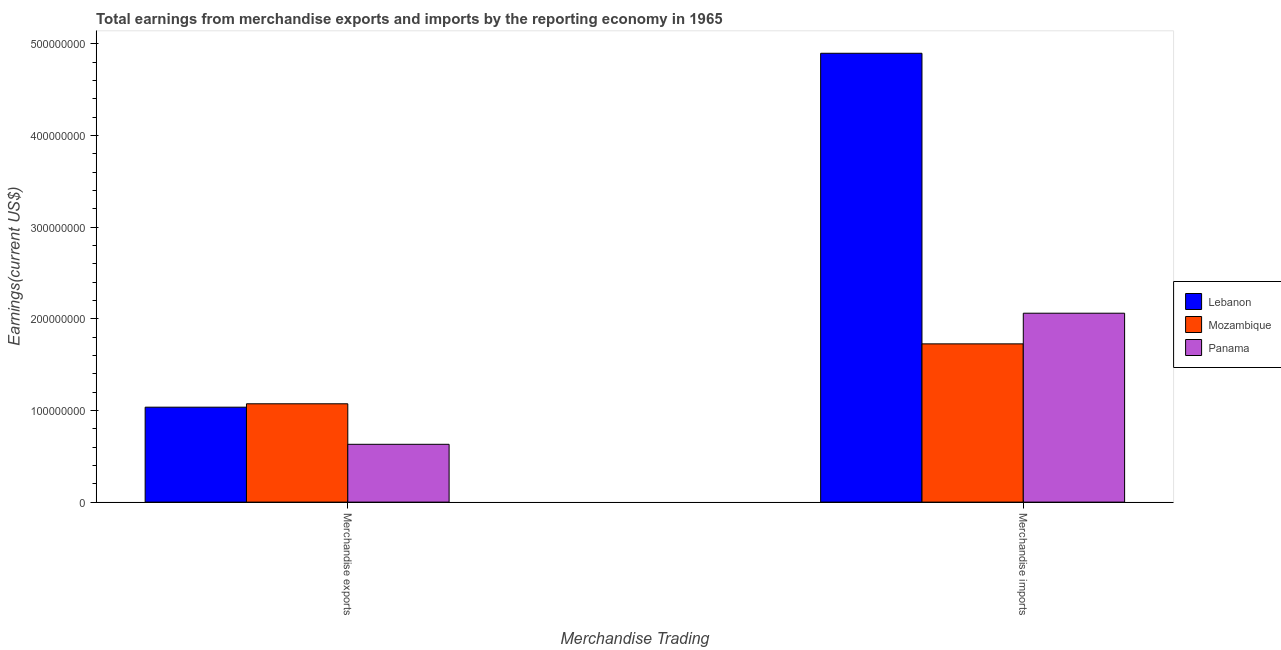How many different coloured bars are there?
Your response must be concise. 3. How many groups of bars are there?
Offer a terse response. 2. Are the number of bars per tick equal to the number of legend labels?
Your response must be concise. Yes. How many bars are there on the 2nd tick from the left?
Offer a very short reply. 3. What is the earnings from merchandise imports in Mozambique?
Your answer should be very brief. 1.73e+08. Across all countries, what is the maximum earnings from merchandise exports?
Provide a succinct answer. 1.07e+08. Across all countries, what is the minimum earnings from merchandise imports?
Make the answer very short. 1.73e+08. In which country was the earnings from merchandise exports maximum?
Keep it short and to the point. Mozambique. In which country was the earnings from merchandise imports minimum?
Your answer should be compact. Mozambique. What is the total earnings from merchandise exports in the graph?
Make the answer very short. 2.74e+08. What is the difference between the earnings from merchandise imports in Lebanon and that in Panama?
Offer a very short reply. 2.84e+08. What is the difference between the earnings from merchandise exports in Lebanon and the earnings from merchandise imports in Mozambique?
Provide a succinct answer. -6.91e+07. What is the average earnings from merchandise imports per country?
Make the answer very short. 2.90e+08. What is the difference between the earnings from merchandise imports and earnings from merchandise exports in Mozambique?
Provide a succinct answer. 6.54e+07. In how many countries, is the earnings from merchandise exports greater than 60000000 US$?
Make the answer very short. 3. What is the ratio of the earnings from merchandise imports in Mozambique to that in Panama?
Offer a very short reply. 0.84. What does the 2nd bar from the left in Merchandise exports represents?
Give a very brief answer. Mozambique. What does the 1st bar from the right in Merchandise imports represents?
Give a very brief answer. Panama. How many countries are there in the graph?
Give a very brief answer. 3. Are the values on the major ticks of Y-axis written in scientific E-notation?
Make the answer very short. No. Does the graph contain grids?
Offer a very short reply. No. How are the legend labels stacked?
Your answer should be compact. Vertical. What is the title of the graph?
Offer a very short reply. Total earnings from merchandise exports and imports by the reporting economy in 1965. What is the label or title of the X-axis?
Your response must be concise. Merchandise Trading. What is the label or title of the Y-axis?
Provide a short and direct response. Earnings(current US$). What is the Earnings(current US$) in Lebanon in Merchandise exports?
Your answer should be very brief. 1.04e+08. What is the Earnings(current US$) in Mozambique in Merchandise exports?
Offer a very short reply. 1.07e+08. What is the Earnings(current US$) of Panama in Merchandise exports?
Offer a very short reply. 6.31e+07. What is the Earnings(current US$) of Lebanon in Merchandise imports?
Your answer should be compact. 4.90e+08. What is the Earnings(current US$) in Mozambique in Merchandise imports?
Provide a succinct answer. 1.73e+08. What is the Earnings(current US$) in Panama in Merchandise imports?
Keep it short and to the point. 2.06e+08. Across all Merchandise Trading, what is the maximum Earnings(current US$) in Lebanon?
Make the answer very short. 4.90e+08. Across all Merchandise Trading, what is the maximum Earnings(current US$) in Mozambique?
Keep it short and to the point. 1.73e+08. Across all Merchandise Trading, what is the maximum Earnings(current US$) in Panama?
Give a very brief answer. 2.06e+08. Across all Merchandise Trading, what is the minimum Earnings(current US$) in Lebanon?
Make the answer very short. 1.04e+08. Across all Merchandise Trading, what is the minimum Earnings(current US$) of Mozambique?
Make the answer very short. 1.07e+08. Across all Merchandise Trading, what is the minimum Earnings(current US$) in Panama?
Your answer should be compact. 6.31e+07. What is the total Earnings(current US$) of Lebanon in the graph?
Offer a terse response. 5.93e+08. What is the total Earnings(current US$) in Mozambique in the graph?
Provide a short and direct response. 2.80e+08. What is the total Earnings(current US$) of Panama in the graph?
Your answer should be very brief. 2.69e+08. What is the difference between the Earnings(current US$) of Lebanon in Merchandise exports and that in Merchandise imports?
Offer a very short reply. -3.86e+08. What is the difference between the Earnings(current US$) of Mozambique in Merchandise exports and that in Merchandise imports?
Keep it short and to the point. -6.54e+07. What is the difference between the Earnings(current US$) in Panama in Merchandise exports and that in Merchandise imports?
Your response must be concise. -1.43e+08. What is the difference between the Earnings(current US$) in Lebanon in Merchandise exports and the Earnings(current US$) in Mozambique in Merchandise imports?
Make the answer very short. -6.91e+07. What is the difference between the Earnings(current US$) in Lebanon in Merchandise exports and the Earnings(current US$) in Panama in Merchandise imports?
Ensure brevity in your answer.  -1.03e+08. What is the difference between the Earnings(current US$) in Mozambique in Merchandise exports and the Earnings(current US$) in Panama in Merchandise imports?
Make the answer very short. -9.88e+07. What is the average Earnings(current US$) of Lebanon per Merchandise Trading?
Make the answer very short. 2.97e+08. What is the average Earnings(current US$) of Mozambique per Merchandise Trading?
Offer a terse response. 1.40e+08. What is the average Earnings(current US$) in Panama per Merchandise Trading?
Your response must be concise. 1.35e+08. What is the difference between the Earnings(current US$) in Lebanon and Earnings(current US$) in Mozambique in Merchandise exports?
Provide a short and direct response. -3.70e+06. What is the difference between the Earnings(current US$) of Lebanon and Earnings(current US$) of Panama in Merchandise exports?
Keep it short and to the point. 4.05e+07. What is the difference between the Earnings(current US$) in Mozambique and Earnings(current US$) in Panama in Merchandise exports?
Make the answer very short. 4.42e+07. What is the difference between the Earnings(current US$) in Lebanon and Earnings(current US$) in Mozambique in Merchandise imports?
Ensure brevity in your answer.  3.17e+08. What is the difference between the Earnings(current US$) of Lebanon and Earnings(current US$) of Panama in Merchandise imports?
Give a very brief answer. 2.84e+08. What is the difference between the Earnings(current US$) in Mozambique and Earnings(current US$) in Panama in Merchandise imports?
Provide a short and direct response. -3.34e+07. What is the ratio of the Earnings(current US$) in Lebanon in Merchandise exports to that in Merchandise imports?
Offer a very short reply. 0.21. What is the ratio of the Earnings(current US$) in Mozambique in Merchandise exports to that in Merchandise imports?
Keep it short and to the point. 0.62. What is the ratio of the Earnings(current US$) in Panama in Merchandise exports to that in Merchandise imports?
Make the answer very short. 0.31. What is the difference between the highest and the second highest Earnings(current US$) of Lebanon?
Your answer should be very brief. 3.86e+08. What is the difference between the highest and the second highest Earnings(current US$) of Mozambique?
Make the answer very short. 6.54e+07. What is the difference between the highest and the second highest Earnings(current US$) in Panama?
Make the answer very short. 1.43e+08. What is the difference between the highest and the lowest Earnings(current US$) in Lebanon?
Provide a short and direct response. 3.86e+08. What is the difference between the highest and the lowest Earnings(current US$) of Mozambique?
Give a very brief answer. 6.54e+07. What is the difference between the highest and the lowest Earnings(current US$) in Panama?
Keep it short and to the point. 1.43e+08. 